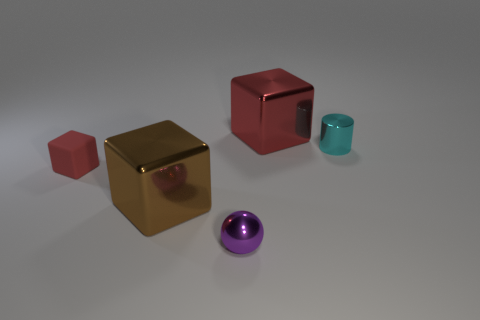Add 3 brown cubes. How many objects exist? 8 Subtract all cubes. How many objects are left? 2 Subtract 0 green cylinders. How many objects are left? 5 Subtract all large cubes. Subtract all metallic blocks. How many objects are left? 1 Add 1 big red objects. How many big red objects are left? 2 Add 2 big gray spheres. How many big gray spheres exist? 2 